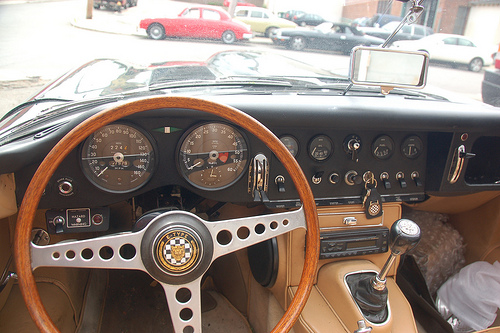<image>
Can you confirm if the red car is behind the black car? No. The red car is not behind the black car. From this viewpoint, the red car appears to be positioned elsewhere in the scene. 